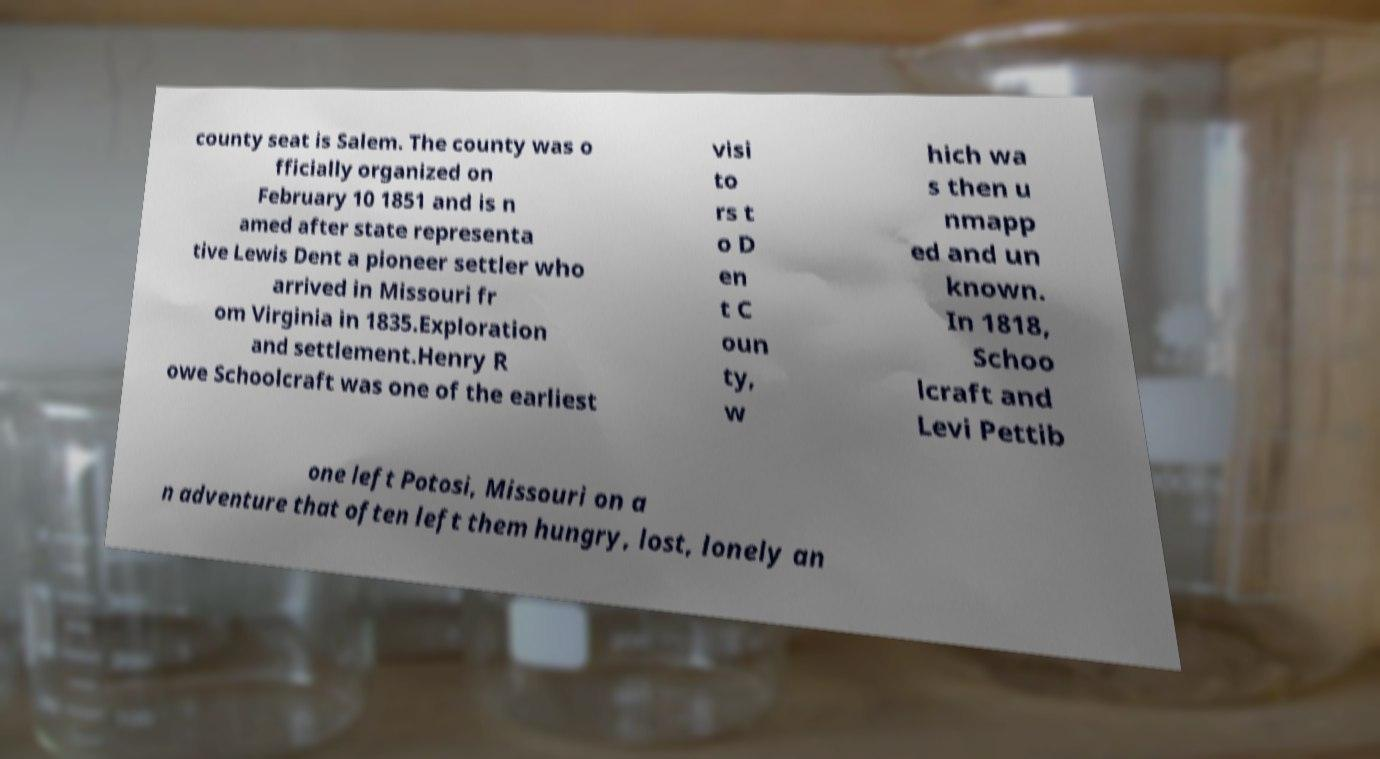Please identify and transcribe the text found in this image. county seat is Salem. The county was o fficially organized on February 10 1851 and is n amed after state representa tive Lewis Dent a pioneer settler who arrived in Missouri fr om Virginia in 1835.Exploration and settlement.Henry R owe Schoolcraft was one of the earliest visi to rs t o D en t C oun ty, w hich wa s then u nmapp ed and un known. In 1818, Schoo lcraft and Levi Pettib one left Potosi, Missouri on a n adventure that often left them hungry, lost, lonely an 